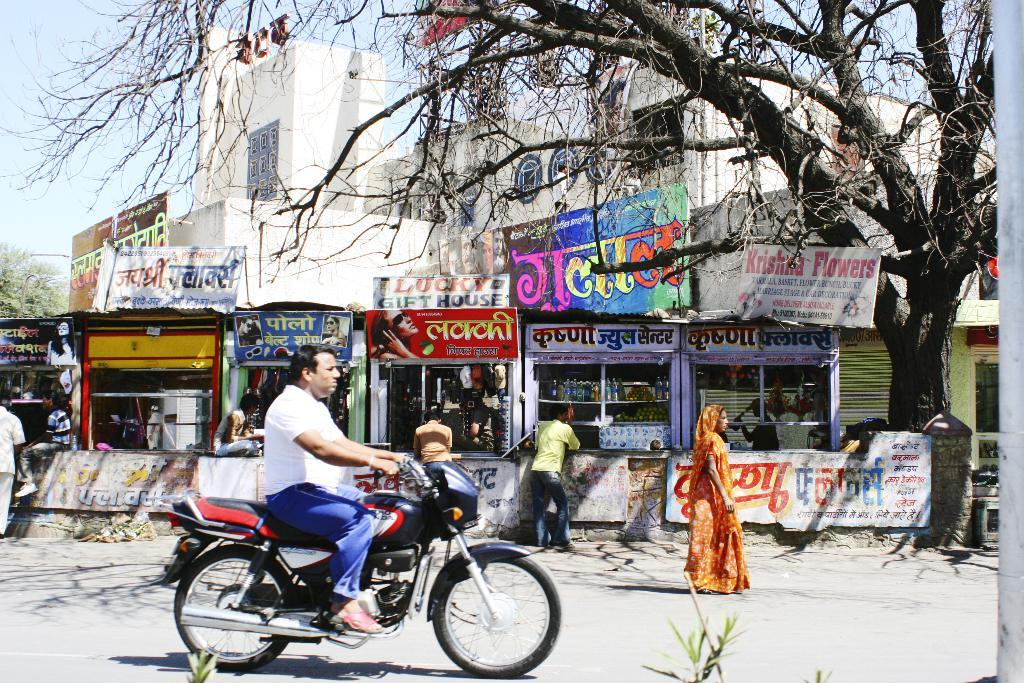Who is the person in the image? There is a man in the image. What is the man doing in the image? The man is sitting on a bike. What can be seen in the background of the image? There are many streets visible in the image. Where was the image taken? The image was clicked on a street. What type of vegetation is on the right side of the image? There is a tree on the right side of the image. What direction is the man facing in the image? The provided facts do not mention the direction the man is facing, so it cannot be determined from the image. --- Facts: 1. There is a cat in the image. 2. The cat is sitting on a chair. 3. The chair is in a room. 4. There is a window in the room. 5. The window has curtains. Absurd Topics: ocean, parrot, dance Conversation: What animal is in the image? There is a cat in the image. What is the cat doing in the image? The cat is sitting on a chair. Where is the chair located? The chair is in a room. What can be seen through the window in the room? The provided facts do not mention what can be seen through the window, so it cannot be determined from the image. What type of window treatment is present in the room? The window has curtains. Reasoning: Let's think step by step in order to produce the conversation. We start by identifying the main subject in the image, which is the cat. Then, we describe what the cat is doing, which is sitting on a chair. Next, we mention the location of the chair, which is in a room. We also mention the presence of a window in the room, but we do not speculate on what can be seen through the window since it is not mentioned in the provided facts. Finally, we describe the window treatment, which is curtains. Absurd Question/Answer: What type of dance is the cat performing in the image? There is no indication in the image that the cat is dancing, so it cannot be determined from the image. 